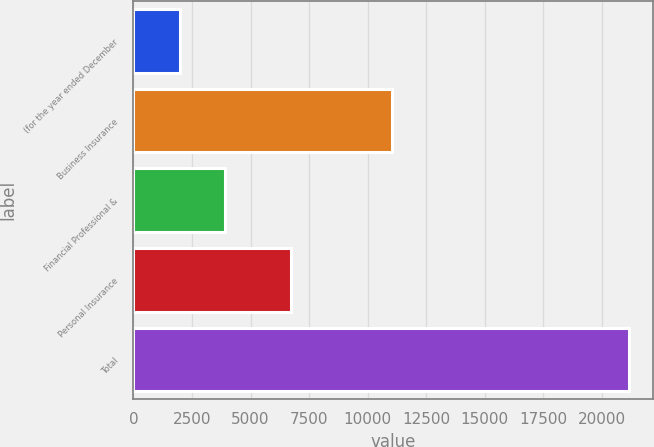<chart> <loc_0><loc_0><loc_500><loc_500><bar_chart><fcel>(for the year ended December<fcel>Business Insurance<fcel>Financial Professional &<fcel>Personal Insurance<fcel>Total<nl><fcel>2006<fcel>11046<fcel>3920.4<fcel>6711<fcel>21150<nl></chart> 